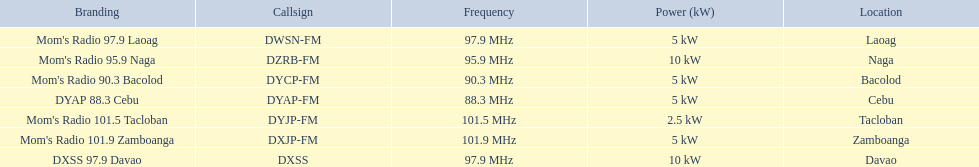What are the stations that transmit on dyap-fm? Mom's Radio 97.9 Laoag, Mom's Radio 95.9 Naga, Mom's Radio 90.3 Bacolod, DYAP 88.3 Cebu, Mom's Radio 101.5 Tacloban, Mom's Radio 101.9 Zamboanga, DXSS 97.9 Davao. Among these stations, which ones have a broadcasting power of 5kw or less? Mom's Radio 97.9 Laoag, Mom's Radio 90.3 Bacolod, DYAP 88.3 Cebu, Mom's Radio 101.5 Tacloban, Mom's Radio 101.9 Zamboanga. Out of these lower-powered stations, which one operates with the lowest power? Mom's Radio 101.5 Tacloban. 